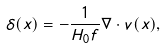Convert formula to latex. <formula><loc_0><loc_0><loc_500><loc_500>\delta ( { x } ) = - \frac { 1 } { H _ { 0 } f } \nabla \cdot { v } ( { x } ) ,</formula> 